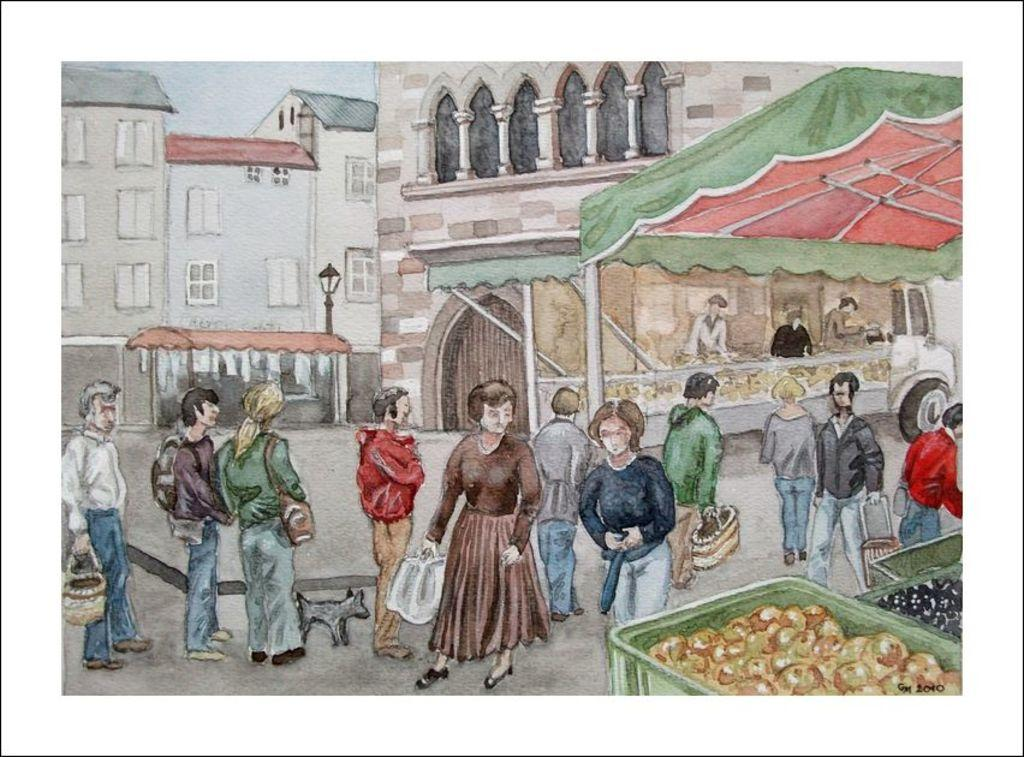What type of temporary shelters can be seen in the image? There are tents in the image. What items are used for carrying or holding in the image? Baskets are present in the image. What type of consumable items are visible in the image? Food items are visible in the image. What objects might be used for storage in the image? Bags are present in the image. What type of living being can be seen in the image? There is an animal in the image. What type of structures are visible in the image? Buildings are visible in the image. What architectural features are present in the image? Windows are present in the image. What type of vertical structure is visible in the image? A light pole is visible in the image. What type of transportation is present in the image? A vehicle is present in the image. What group of people can be seen in the image? There is a group of people on the ground in the image. What additional objects are present in the image? There are some objects in the image. How does the creature control the vehicle in the image? There is no creature present in the image, and therefore no control of the vehicle can be observed. 